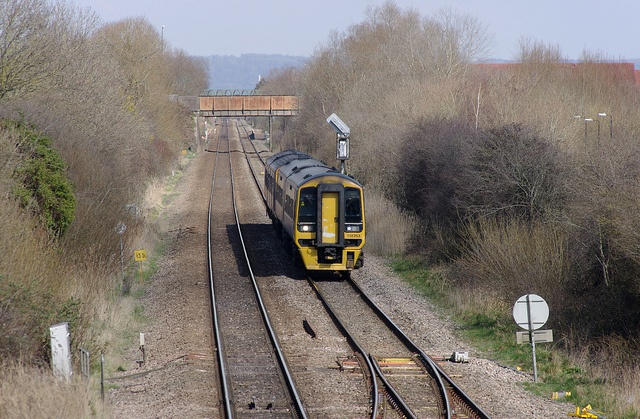Describe the objects in this image and their specific colors. I can see a train in darkgray, black, gray, and olive tones in this image. 